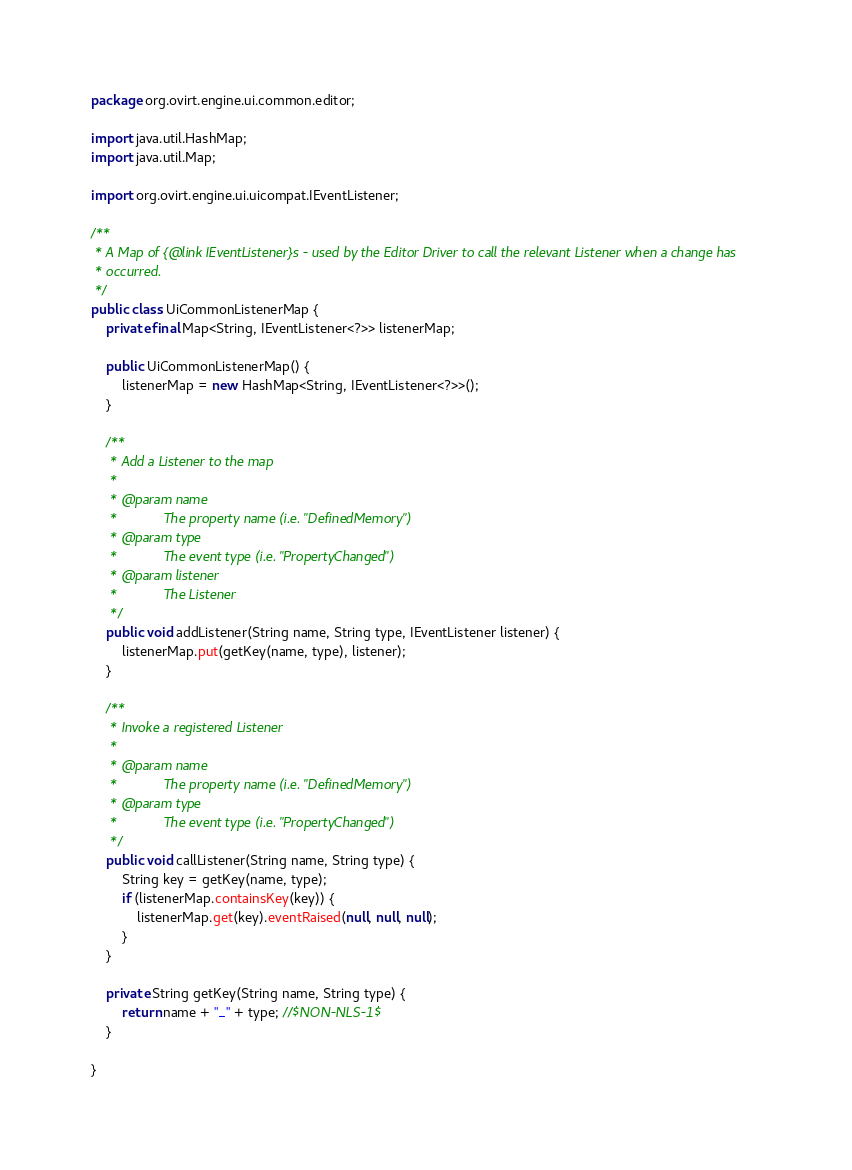<code> <loc_0><loc_0><loc_500><loc_500><_Java_>package org.ovirt.engine.ui.common.editor;

import java.util.HashMap;
import java.util.Map;

import org.ovirt.engine.ui.uicompat.IEventListener;

/**
 * A Map of {@link IEventListener}s - used by the Editor Driver to call the relevant Listener when a change has
 * occurred.
 */
public class UiCommonListenerMap {
    private final Map<String, IEventListener<?>> listenerMap;

    public UiCommonListenerMap() {
        listenerMap = new HashMap<String, IEventListener<?>>();
    }

    /**
     * Add a Listener to the map
     *
     * @param name
     *            The property name (i.e. "DefinedMemory")
     * @param type
     *            The event type (i.e. "PropertyChanged")
     * @param listener
     *            The Listener
     */
    public void addListener(String name, String type, IEventListener listener) {
        listenerMap.put(getKey(name, type), listener);
    }

    /**
     * Invoke a registered Listener
     *
     * @param name
     *            The property name (i.e. "DefinedMemory")
     * @param type
     *            The event type (i.e. "PropertyChanged")
     */
    public void callListener(String name, String type) {
        String key = getKey(name, type);
        if (listenerMap.containsKey(key)) {
            listenerMap.get(key).eventRaised(null, null, null);
        }
    }

    private String getKey(String name, String type) {
        return name + "_" + type; //$NON-NLS-1$
    }

}
</code> 